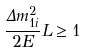<formula> <loc_0><loc_0><loc_500><loc_500>\frac { \Delta m ^ { 2 } _ { 1 i } } { 2 E } L \geq 1</formula> 